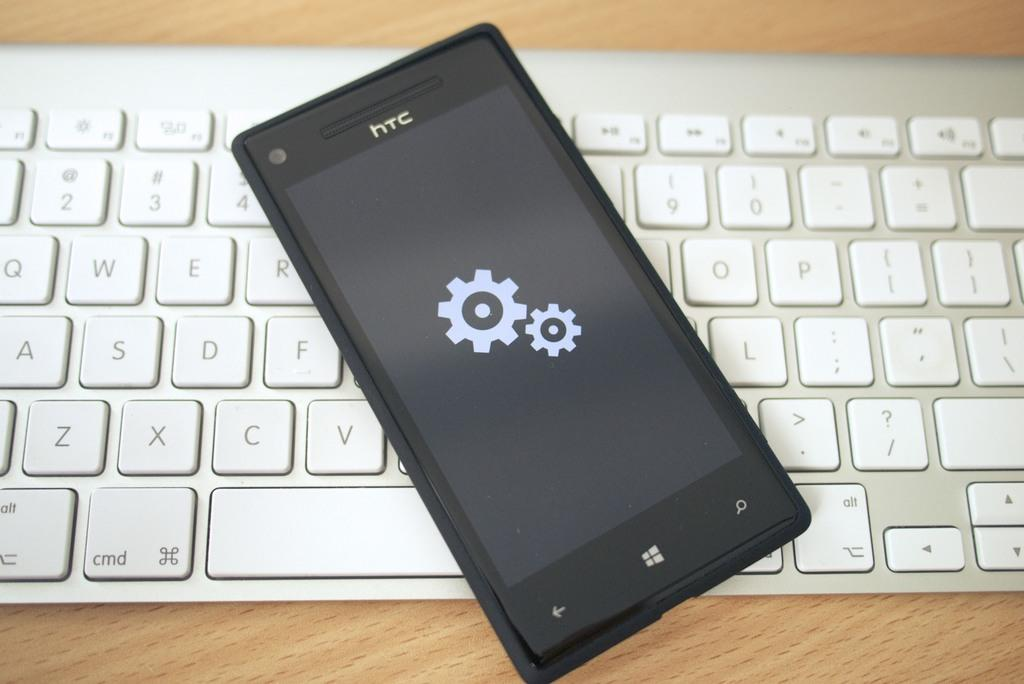Provide a one-sentence caption for the provided image. Black HTC cellphone on top of a white keyboard. 